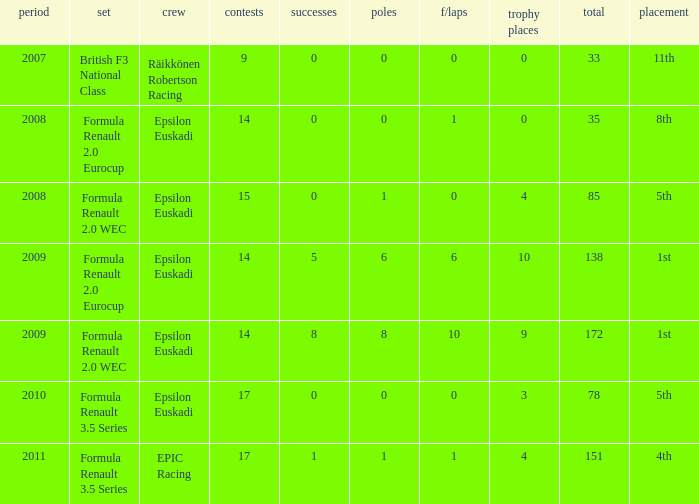How many podiums when he was in the british f3 national class series? 1.0. 